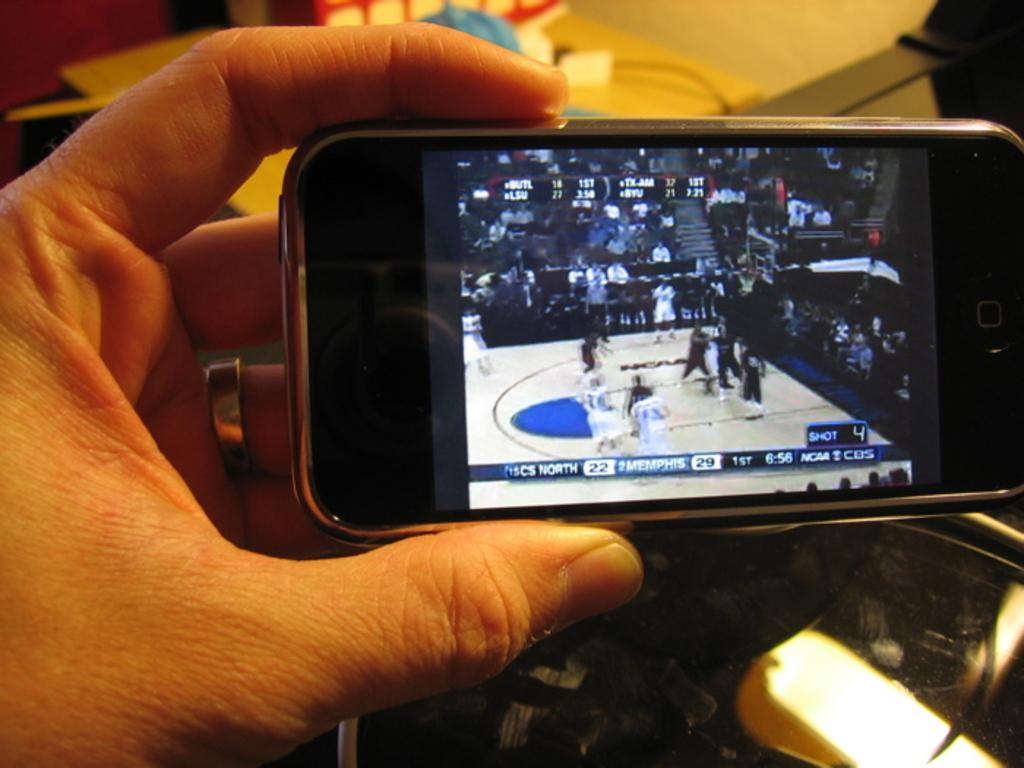<image>
Write a terse but informative summary of the picture. A basketball game being displayed on a cell phone where Memphis has 29 points. 